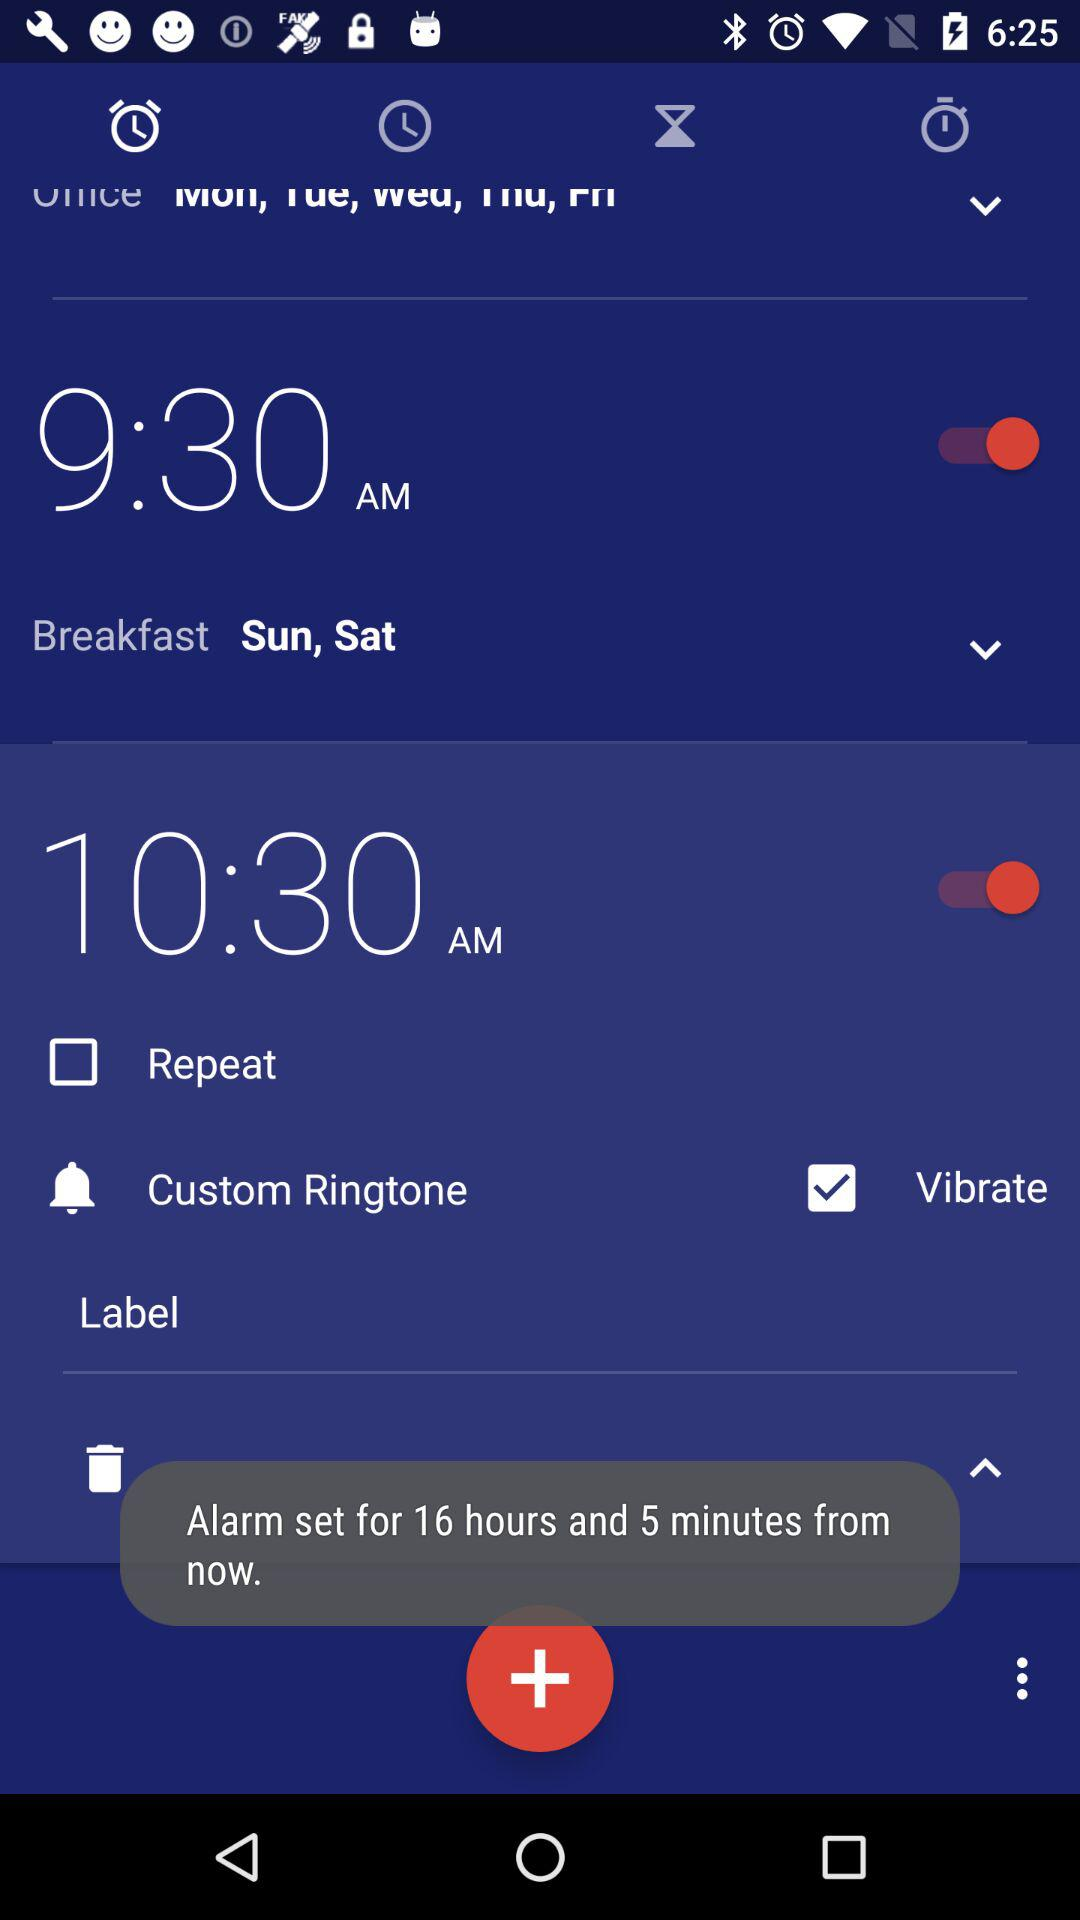What is the alarm time for breakfast? The alarm time for breakfast is 9:30 AM. 